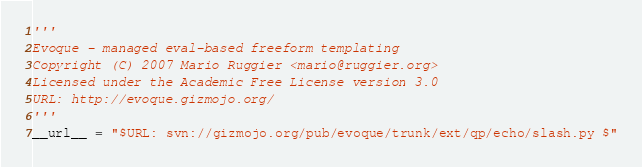Convert code to text. <code><loc_0><loc_0><loc_500><loc_500><_Python_>'''
Evoque - managed eval-based freeform templating 
Copyright (C) 2007 Mario Ruggier <mario@ruggier.org>
Licensed under the Academic Free License version 3.0
URL: http://evoque.gizmojo.org/
'''
__url__ = "$URL: svn://gizmojo.org/pub/evoque/trunk/ext/qp/echo/slash.py $"</code> 